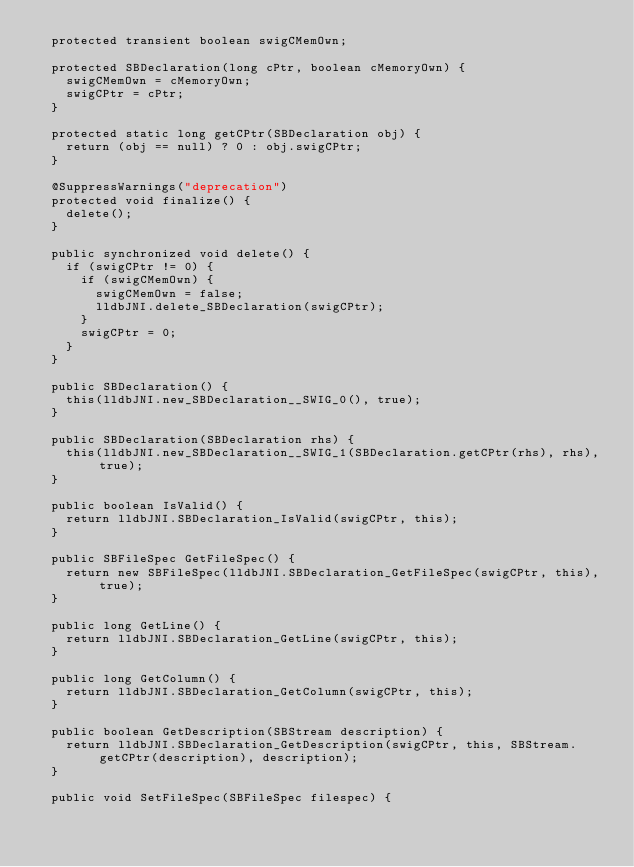<code> <loc_0><loc_0><loc_500><loc_500><_Java_>  protected transient boolean swigCMemOwn;

  protected SBDeclaration(long cPtr, boolean cMemoryOwn) {
    swigCMemOwn = cMemoryOwn;
    swigCPtr = cPtr;
  }

  protected static long getCPtr(SBDeclaration obj) {
    return (obj == null) ? 0 : obj.swigCPtr;
  }

  @SuppressWarnings("deprecation")
  protected void finalize() {
    delete();
  }

  public synchronized void delete() {
    if (swigCPtr != 0) {
      if (swigCMemOwn) {
        swigCMemOwn = false;
        lldbJNI.delete_SBDeclaration(swigCPtr);
      }
      swigCPtr = 0;
    }
  }

  public SBDeclaration() {
    this(lldbJNI.new_SBDeclaration__SWIG_0(), true);
  }

  public SBDeclaration(SBDeclaration rhs) {
    this(lldbJNI.new_SBDeclaration__SWIG_1(SBDeclaration.getCPtr(rhs), rhs), true);
  }

  public boolean IsValid() {
    return lldbJNI.SBDeclaration_IsValid(swigCPtr, this);
  }

  public SBFileSpec GetFileSpec() {
    return new SBFileSpec(lldbJNI.SBDeclaration_GetFileSpec(swigCPtr, this), true);
  }

  public long GetLine() {
    return lldbJNI.SBDeclaration_GetLine(swigCPtr, this);
  }

  public long GetColumn() {
    return lldbJNI.SBDeclaration_GetColumn(swigCPtr, this);
  }

  public boolean GetDescription(SBStream description) {
    return lldbJNI.SBDeclaration_GetDescription(swigCPtr, this, SBStream.getCPtr(description), description);
  }

  public void SetFileSpec(SBFileSpec filespec) {</code> 